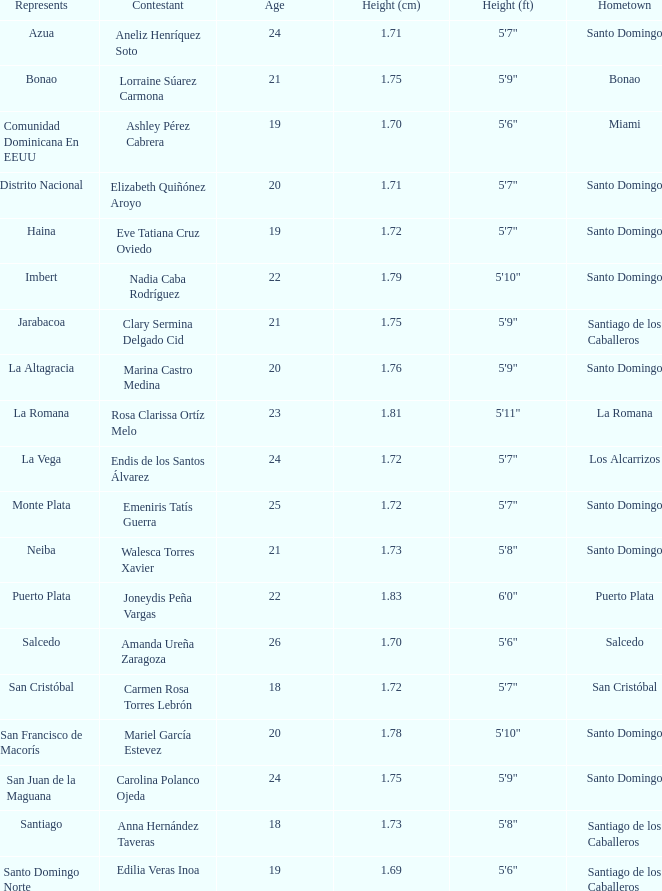Would you be able to parse every entry in this table? {'header': ['Represents', 'Contestant', 'Age', 'Height (cm)', 'Height (ft)', 'Hometown'], 'rows': [['Azua', 'Aneliz Henríquez Soto', '24', '1.71', '5\'7"', 'Santo Domingo'], ['Bonao', 'Lorraine Súarez Carmona', '21', '1.75', '5\'9"', 'Bonao'], ['Comunidad Dominicana En EEUU', 'Ashley Pérez Cabrera', '19', '1.70', '5\'6"', 'Miami'], ['Distrito Nacional', 'Elizabeth Quiñónez Aroyo', '20', '1.71', '5\'7"', 'Santo Domingo'], ['Haina', 'Eve Tatiana Cruz Oviedo', '19', '1.72', '5\'7"', 'Santo Domingo'], ['Imbert', 'Nadia Caba Rodríguez', '22', '1.79', '5\'10"', 'Santo Domingo'], ['Jarabacoa', 'Clary Sermina Delgado Cid', '21', '1.75', '5\'9"', 'Santiago de los Caballeros'], ['La Altagracia', 'Marina Castro Medina', '20', '1.76', '5\'9"', 'Santo Domingo'], ['La Romana', 'Rosa Clarissa Ortíz Melo', '23', '1.81', '5\'11"', 'La Romana'], ['La Vega', 'Endis de los Santos Álvarez', '24', '1.72', '5\'7"', 'Los Alcarrizos'], ['Monte Plata', 'Emeniris Tatís Guerra', '25', '1.72', '5\'7"', 'Santo Domingo'], ['Neiba', 'Walesca Torres Xavier', '21', '1.73', '5\'8"', 'Santo Domingo'], ['Puerto Plata', 'Joneydis Peña Vargas', '22', '1.83', '6\'0"', 'Puerto Plata'], ['Salcedo', 'Amanda Ureña Zaragoza', '26', '1.70', '5\'6"', 'Salcedo'], ['San Cristóbal', 'Carmen Rosa Torres Lebrón', '18', '1.72', '5\'7"', 'San Cristóbal'], ['San Francisco de Macorís', 'Mariel García Estevez', '20', '1.78', '5\'10"', 'Santo Domingo'], ['San Juan de la Maguana', 'Carolina Polanco Ojeda', '24', '1.75', '5\'9"', 'Santo Domingo'], ['Santiago', 'Anna Hernández Taveras', '18', '1.73', '5\'8"', 'Santiago de los Caballeros'], ['Santo Domingo Norte', 'Edilia Veras Inoa', '19', '1.69', '5\'6"', 'Santiago de los Caballeros']]} Determine the earliest age 26.0. 